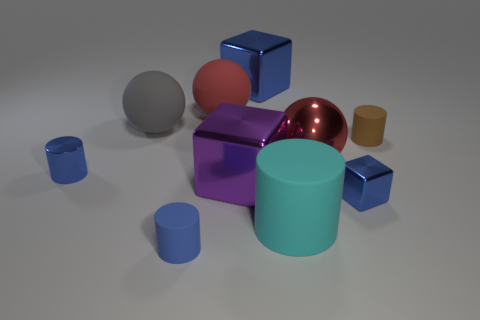Subtract all brown cylinders. How many cylinders are left? 3 Subtract 1 cylinders. How many cylinders are left? 3 Subtract all cyan rubber cylinders. How many cylinders are left? 3 Subtract all purple cylinders. Subtract all green balls. How many cylinders are left? 4 Subtract all spheres. How many objects are left? 7 Add 3 large spheres. How many large spheres exist? 6 Subtract 0 yellow blocks. How many objects are left? 10 Subtract all small matte objects. Subtract all metallic objects. How many objects are left? 3 Add 7 large cylinders. How many large cylinders are left? 8 